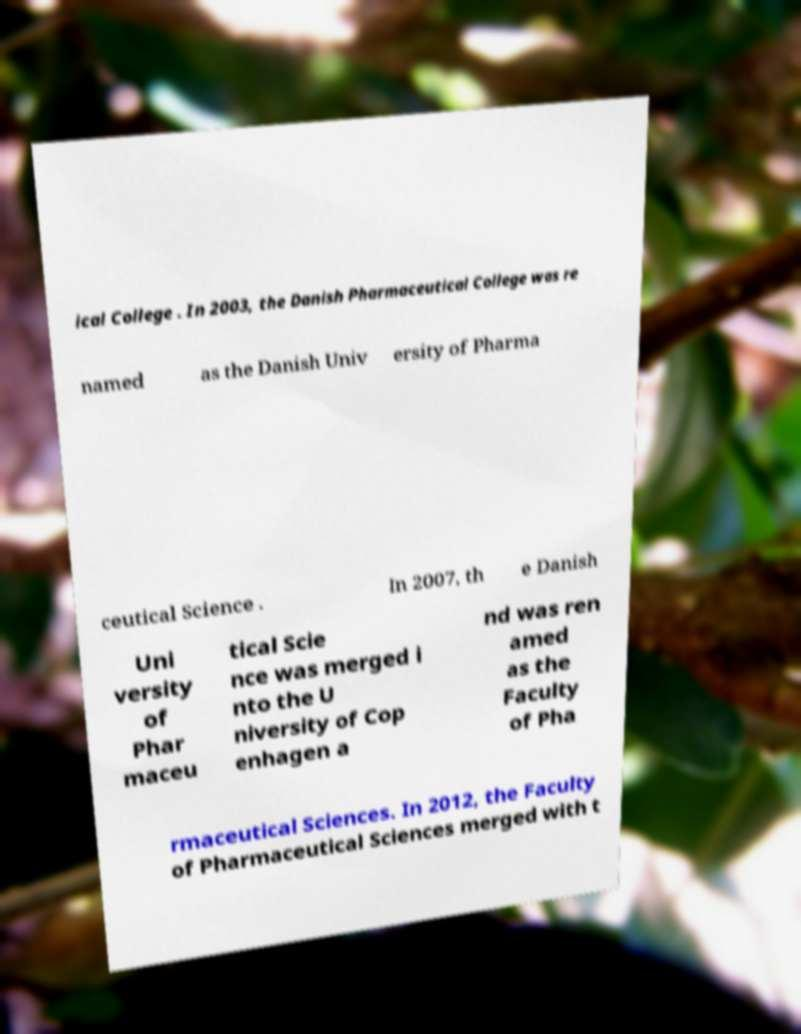Could you extract and type out the text from this image? ical College . In 2003, the Danish Pharmaceutical College was re named as the Danish Univ ersity of Pharma ceutical Science . In 2007, th e Danish Uni versity of Phar maceu tical Scie nce was merged i nto the U niversity of Cop enhagen a nd was ren amed as the Faculty of Pha rmaceutical Sciences. In 2012, the Faculty of Pharmaceutical Sciences merged with t 